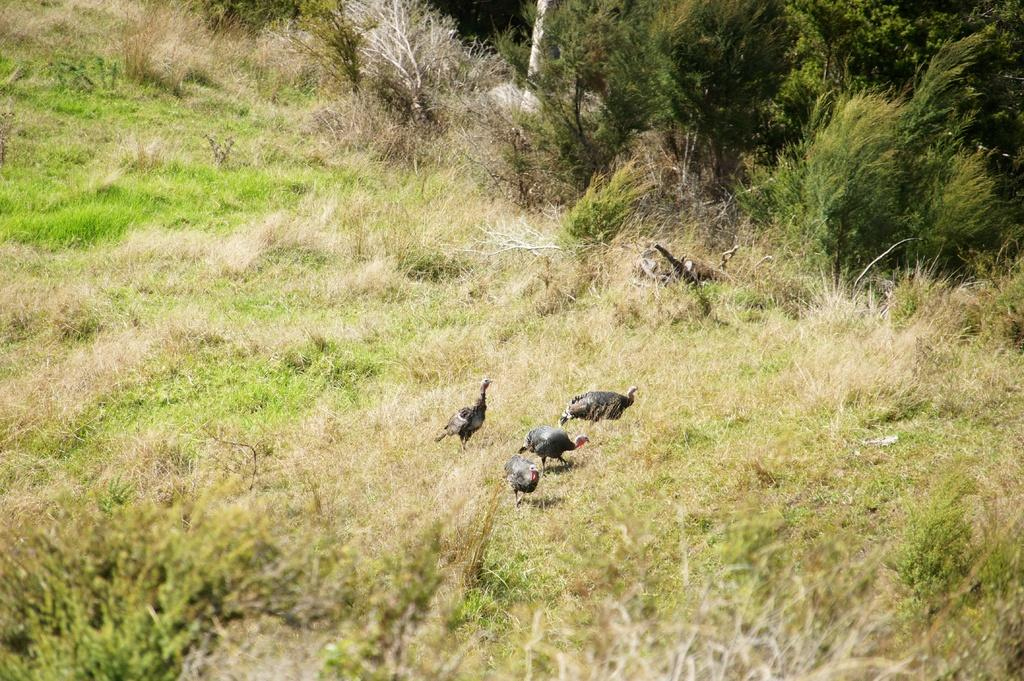What type of animals can be seen in the image? There are birds in the image. What are the birds doing in the image? The birds are walking on the grassland. What can be seen in the background of the image? There are trees visible in the background of the image. What type of berry can be seen in the image? There is no berry present in the image. How many rabbits can be seen in the image? There are no rabbits present in the image. 